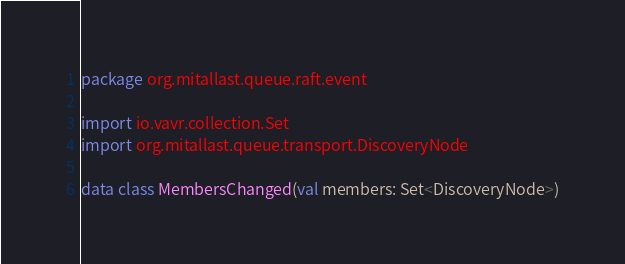<code> <loc_0><loc_0><loc_500><loc_500><_Kotlin_>package org.mitallast.queue.raft.event

import io.vavr.collection.Set
import org.mitallast.queue.transport.DiscoveryNode

data class MembersChanged(val members: Set<DiscoveryNode>)
</code> 